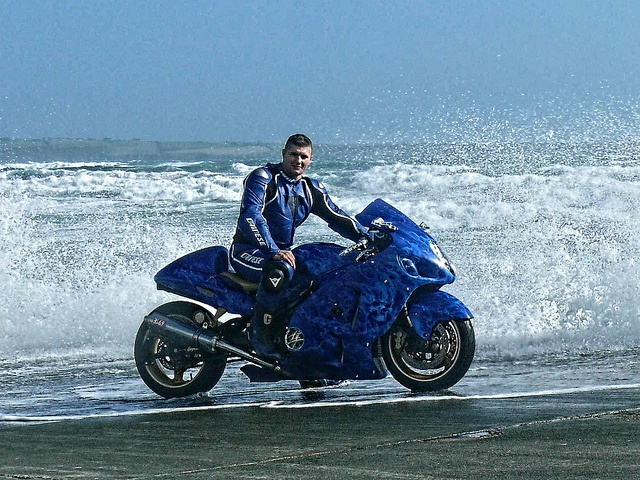Describe the objects in this image and their specific colors. I can see motorcycle in lightblue, black, navy, gray, and lightgray tones and people in lightblue, black, navy, gray, and white tones in this image. 